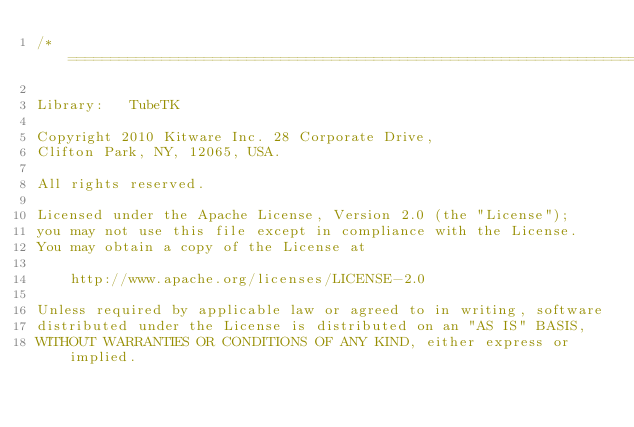<code> <loc_0><loc_0><loc_500><loc_500><_C++_>/*=========================================================================

Library:   TubeTK

Copyright 2010 Kitware Inc. 28 Corporate Drive,
Clifton Park, NY, 12065, USA.

All rights reserved.

Licensed under the Apache License, Version 2.0 (the "License");
you may not use this file except in compliance with the License.
You may obtain a copy of the License at

    http://www.apache.org/licenses/LICENSE-2.0

Unless required by applicable law or agreed to in writing, software
distributed under the License is distributed on an "AS IS" BASIS,
WITHOUT WARRANTIES OR CONDITIONS OF ANY KIND, either express or implied.</code> 